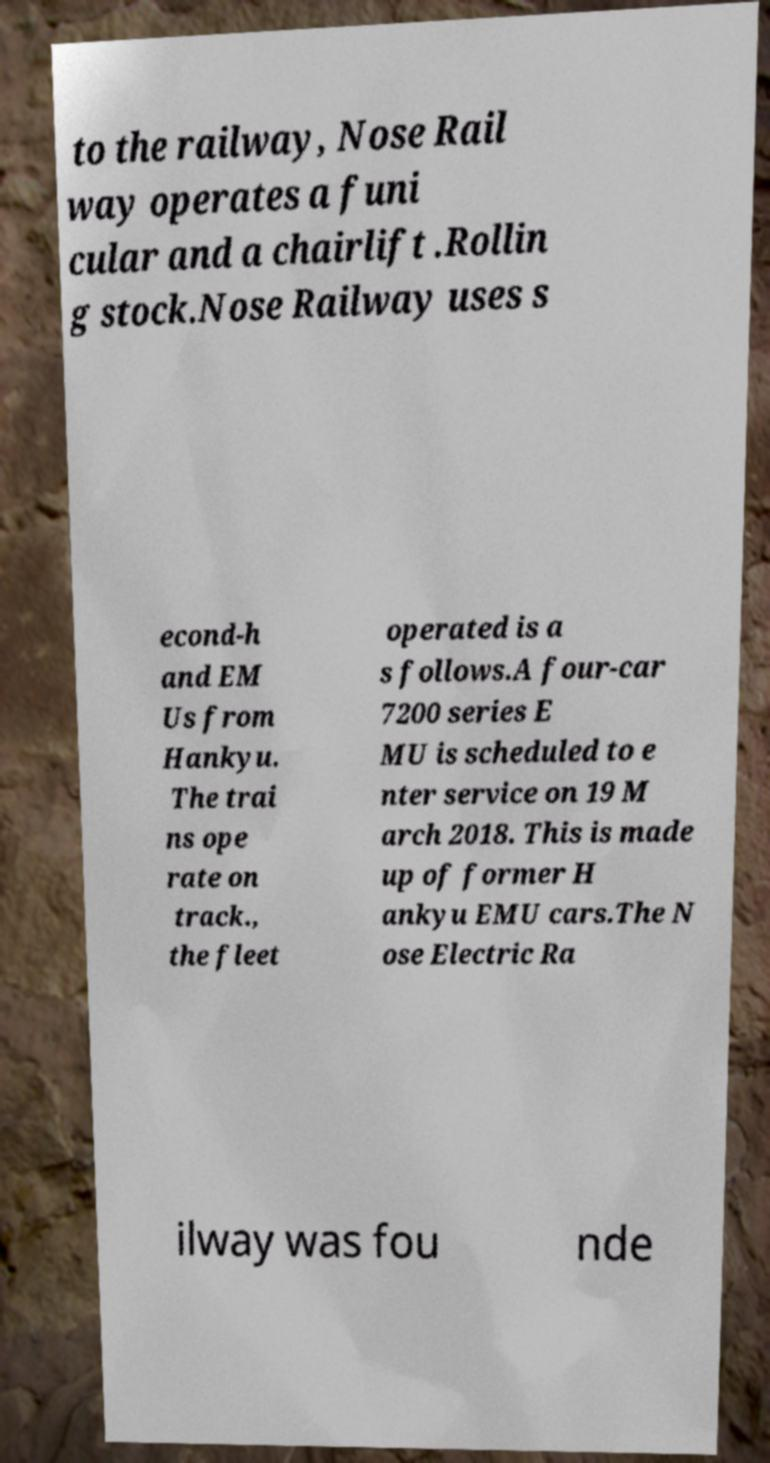Could you extract and type out the text from this image? to the railway, Nose Rail way operates a funi cular and a chairlift .Rollin g stock.Nose Railway uses s econd-h and EM Us from Hankyu. The trai ns ope rate on track., the fleet operated is a s follows.A four-car 7200 series E MU is scheduled to e nter service on 19 M arch 2018. This is made up of former H ankyu EMU cars.The N ose Electric Ra ilway was fou nde 